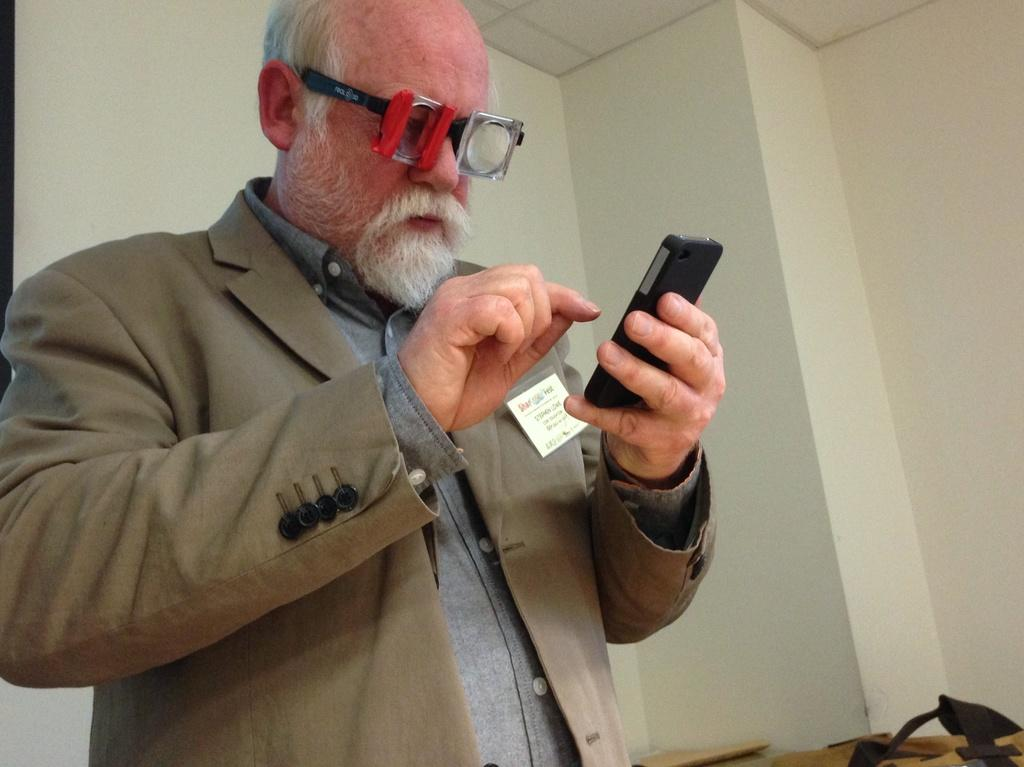What is the main subject of the image? The main subject of the image is a man. What is the man doing in the image? The man is standing in the image. What can be seen on the man's face? The man is wearing spectacles in the image. What object is the man holding? The man is holding a mobile in the image. What can be seen in the background of the image? There is a wall and a table in the background of the image. How many snakes are slithering on the table in the image? There are no snakes present in the image; the table is empty. What is the man's income based on the image? There is no information about the man's income in the image. 